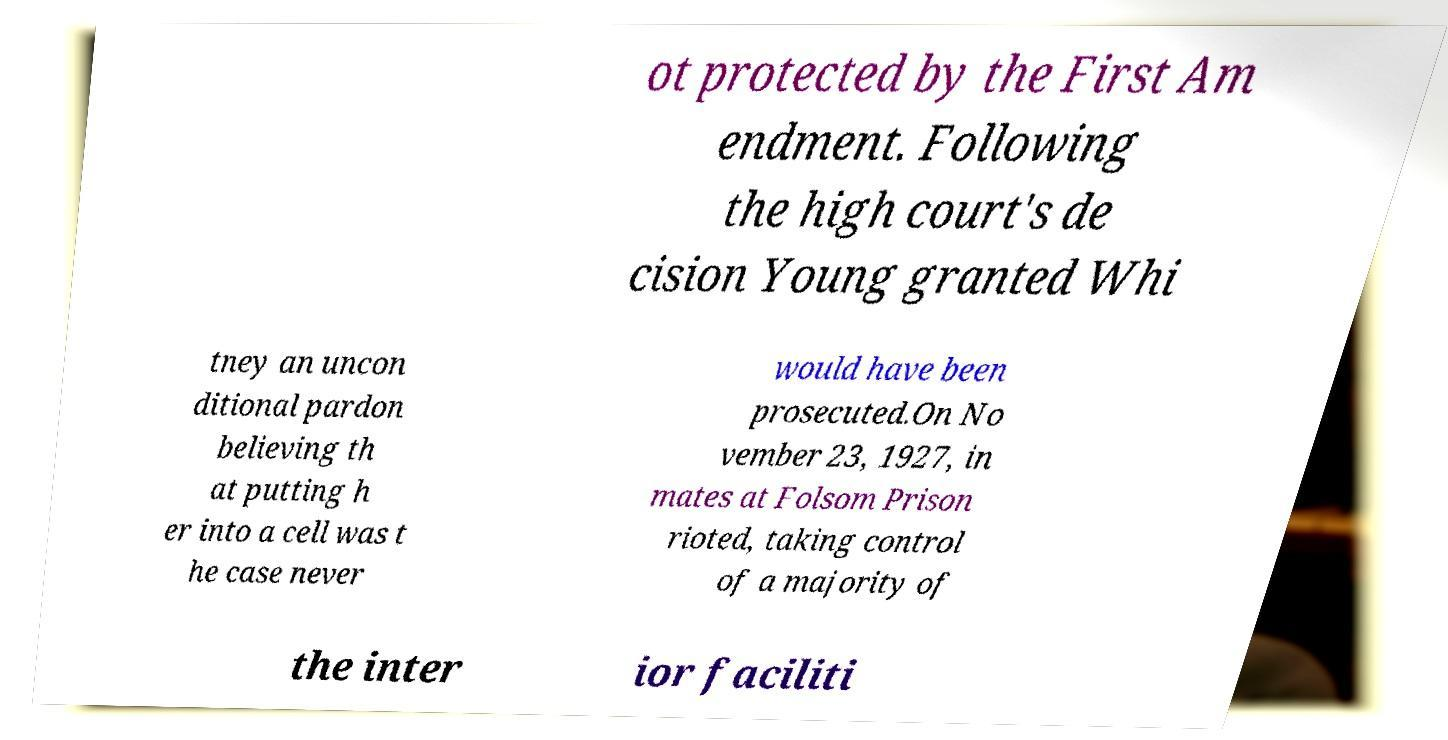Could you extract and type out the text from this image? ot protected by the First Am endment. Following the high court's de cision Young granted Whi tney an uncon ditional pardon believing th at putting h er into a cell was t he case never would have been prosecuted.On No vember 23, 1927, in mates at Folsom Prison rioted, taking control of a majority of the inter ior faciliti 